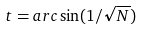Convert formula to latex. <formula><loc_0><loc_0><loc_500><loc_500>t = a r c \sin ( 1 / \sqrt { N } )</formula> 